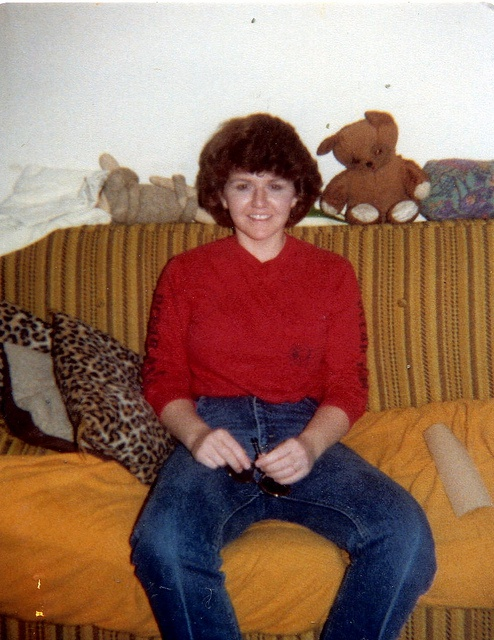Describe the objects in this image and their specific colors. I can see couch in white, olive, maroon, and black tones, people in white, maroon, black, and navy tones, teddy bear in white, maroon, and brown tones, and teddy bear in white, gray, tan, and brown tones in this image. 